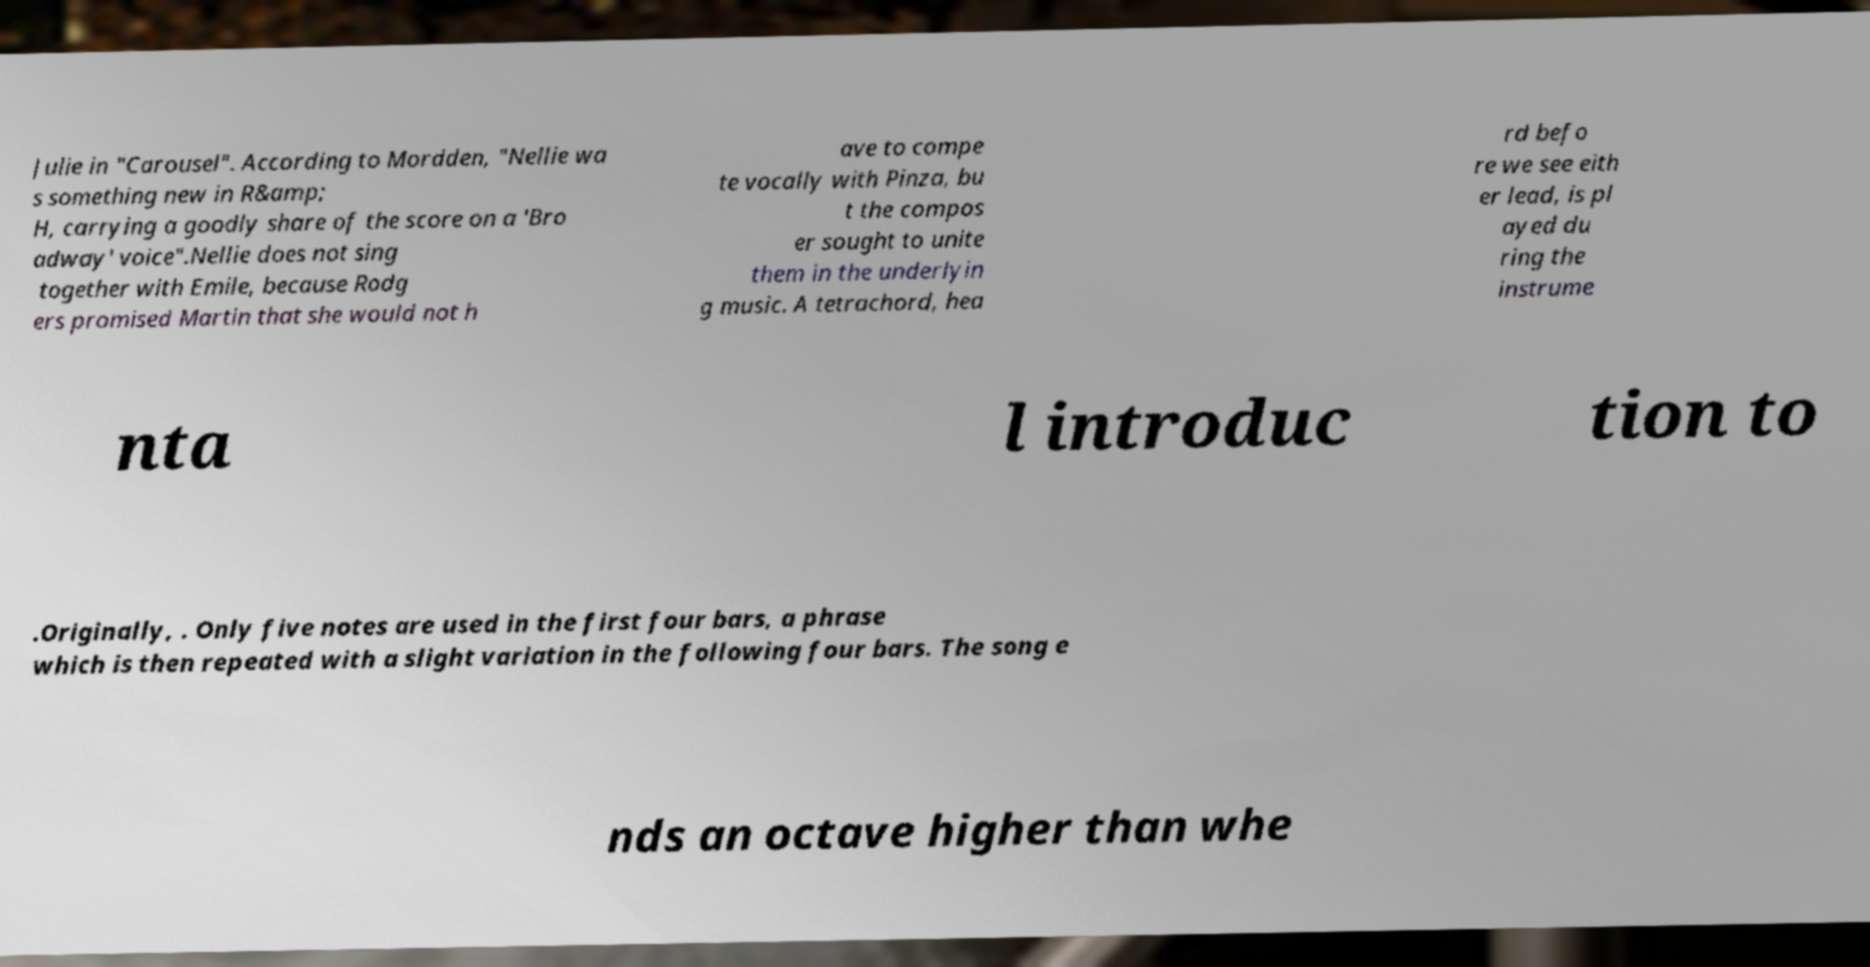Can you accurately transcribe the text from the provided image for me? Julie in "Carousel". According to Mordden, "Nellie wa s something new in R&amp; H, carrying a goodly share of the score on a 'Bro adway' voice".Nellie does not sing together with Emile, because Rodg ers promised Martin that she would not h ave to compe te vocally with Pinza, bu t the compos er sought to unite them in the underlyin g music. A tetrachord, hea rd befo re we see eith er lead, is pl ayed du ring the instrume nta l introduc tion to .Originally, . Only five notes are used in the first four bars, a phrase which is then repeated with a slight variation in the following four bars. The song e nds an octave higher than whe 